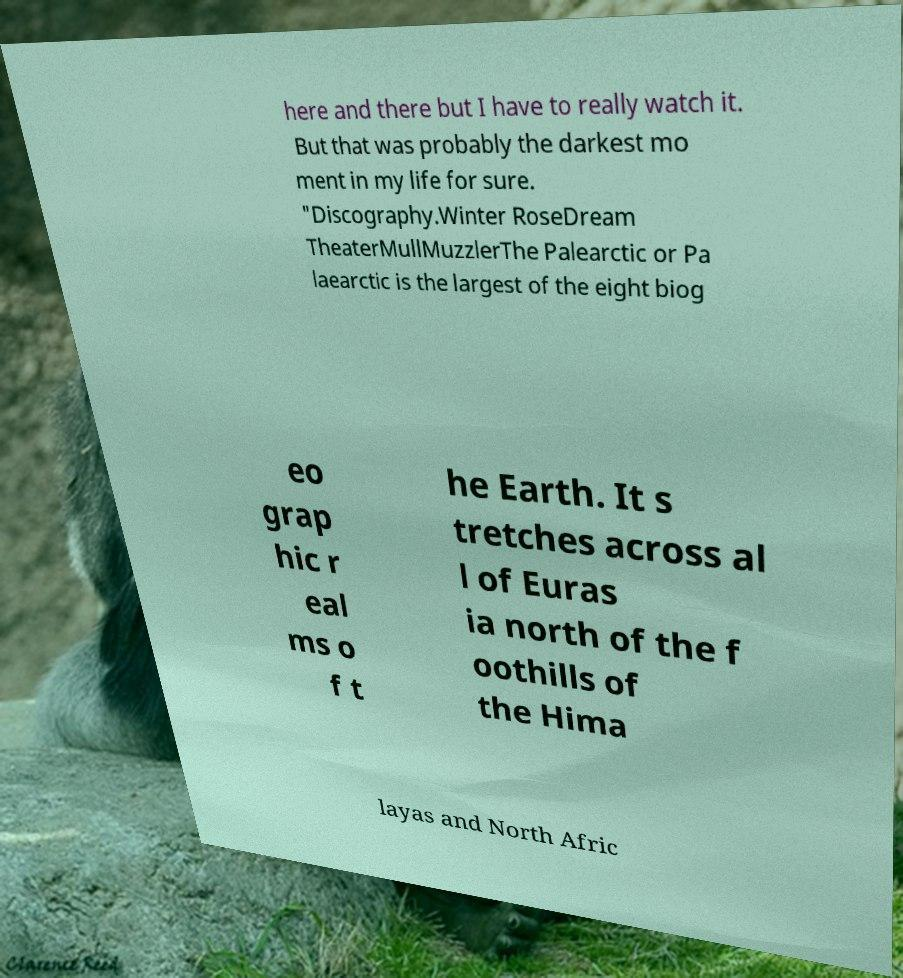Please identify and transcribe the text found in this image. here and there but I have to really watch it. But that was probably the darkest mo ment in my life for sure. "Discography.Winter RoseDream TheaterMullMuzzlerThe Palearctic or Pa laearctic is the largest of the eight biog eo grap hic r eal ms o f t he Earth. It s tretches across al l of Euras ia north of the f oothills of the Hima layas and North Afric 